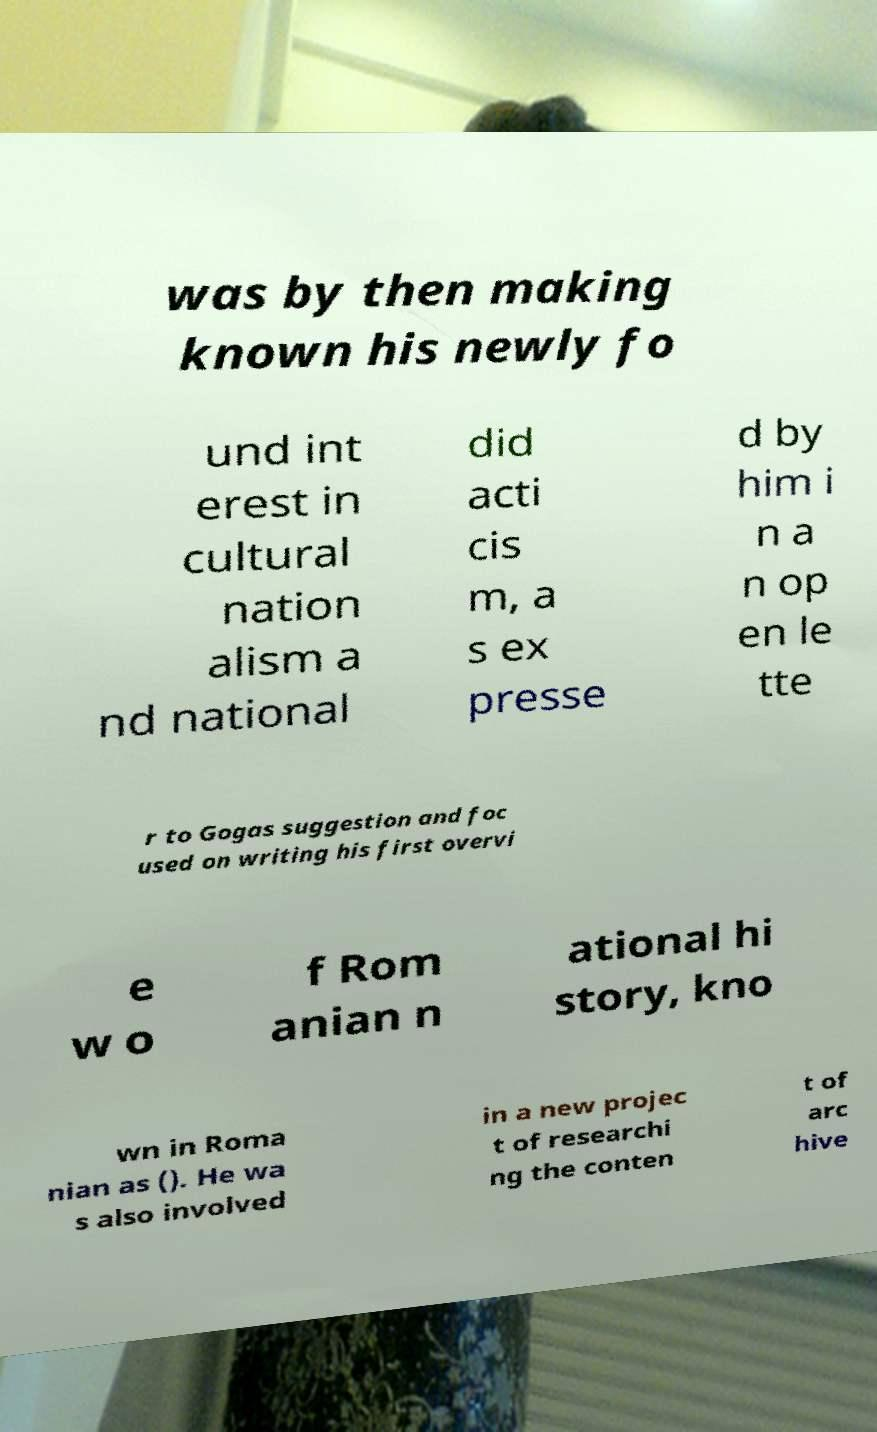Can you read and provide the text displayed in the image?This photo seems to have some interesting text. Can you extract and type it out for me? was by then making known his newly fo und int erest in cultural nation alism a nd national did acti cis m, a s ex presse d by him i n a n op en le tte r to Gogas suggestion and foc used on writing his first overvi e w o f Rom anian n ational hi story, kno wn in Roma nian as (). He wa s also involved in a new projec t of researchi ng the conten t of arc hive 